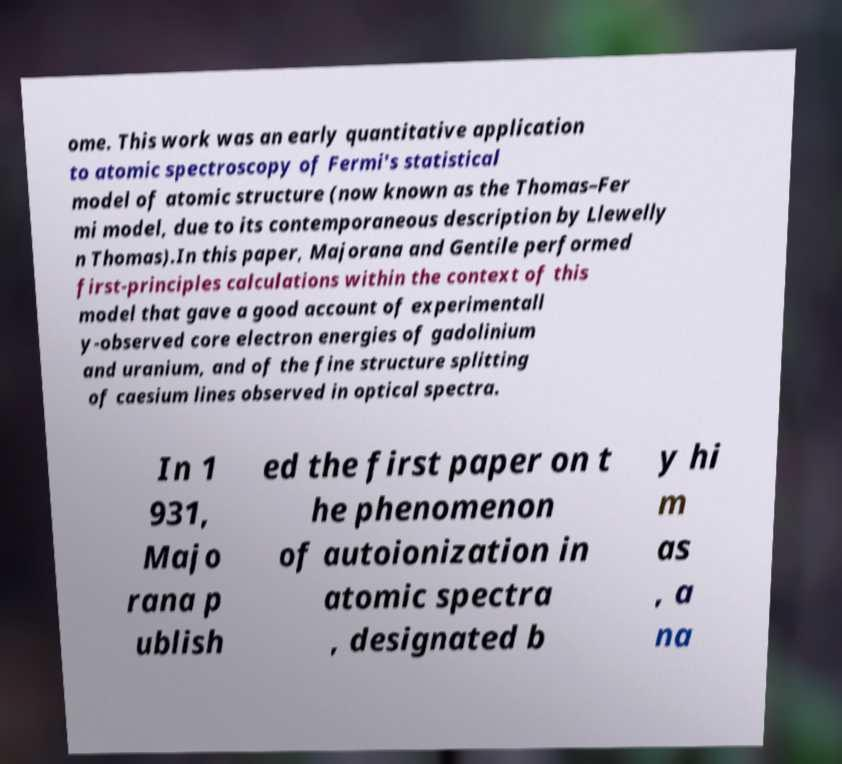For documentation purposes, I need the text within this image transcribed. Could you provide that? ome. This work was an early quantitative application to atomic spectroscopy of Fermi's statistical model of atomic structure (now known as the Thomas–Fer mi model, due to its contemporaneous description by Llewelly n Thomas).In this paper, Majorana and Gentile performed first-principles calculations within the context of this model that gave a good account of experimentall y-observed core electron energies of gadolinium and uranium, and of the fine structure splitting of caesium lines observed in optical spectra. In 1 931, Majo rana p ublish ed the first paper on t he phenomenon of autoionization in atomic spectra , designated b y hi m as , a na 